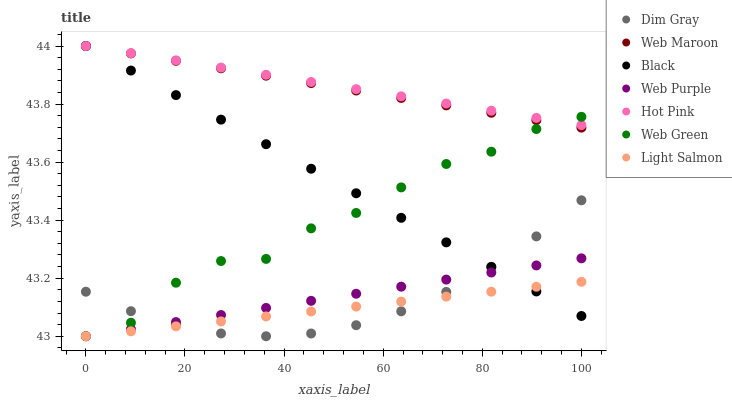Does Light Salmon have the minimum area under the curve?
Answer yes or no. Yes. Does Hot Pink have the maximum area under the curve?
Answer yes or no. Yes. Does Dim Gray have the minimum area under the curve?
Answer yes or no. No. Does Dim Gray have the maximum area under the curve?
Answer yes or no. No. Is Web Maroon the smoothest?
Answer yes or no. Yes. Is Web Green the roughest?
Answer yes or no. Yes. Is Dim Gray the smoothest?
Answer yes or no. No. Is Dim Gray the roughest?
Answer yes or no. No. Does Light Salmon have the lowest value?
Answer yes or no. Yes. Does Dim Gray have the lowest value?
Answer yes or no. No. Does Black have the highest value?
Answer yes or no. Yes. Does Dim Gray have the highest value?
Answer yes or no. No. Is Web Purple less than Web Maroon?
Answer yes or no. Yes. Is Web Maroon greater than Dim Gray?
Answer yes or no. Yes. Does Black intersect Web Purple?
Answer yes or no. Yes. Is Black less than Web Purple?
Answer yes or no. No. Is Black greater than Web Purple?
Answer yes or no. No. Does Web Purple intersect Web Maroon?
Answer yes or no. No. 